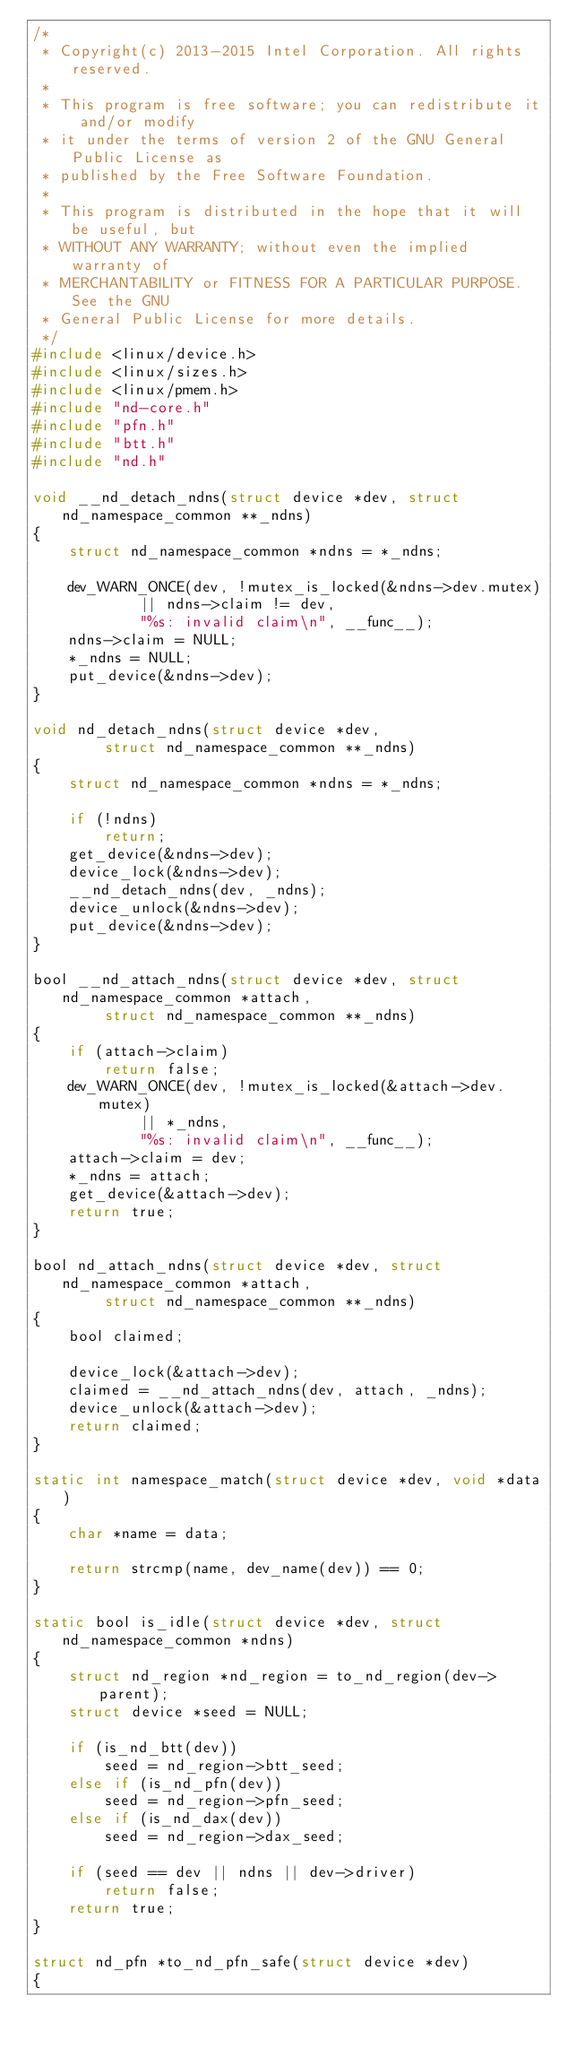Convert code to text. <code><loc_0><loc_0><loc_500><loc_500><_C_>/*
 * Copyright(c) 2013-2015 Intel Corporation. All rights reserved.
 *
 * This program is free software; you can redistribute it and/or modify
 * it under the terms of version 2 of the GNU General Public License as
 * published by the Free Software Foundation.
 *
 * This program is distributed in the hope that it will be useful, but
 * WITHOUT ANY WARRANTY; without even the implied warranty of
 * MERCHANTABILITY or FITNESS FOR A PARTICULAR PURPOSE.  See the GNU
 * General Public License for more details.
 */
#include <linux/device.h>
#include <linux/sizes.h>
#include <linux/pmem.h>
#include "nd-core.h"
#include "pfn.h"
#include "btt.h"
#include "nd.h"

void __nd_detach_ndns(struct device *dev, struct nd_namespace_common **_ndns)
{
	struct nd_namespace_common *ndns = *_ndns;

	dev_WARN_ONCE(dev, !mutex_is_locked(&ndns->dev.mutex)
			|| ndns->claim != dev,
			"%s: invalid claim\n", __func__);
	ndns->claim = NULL;
	*_ndns = NULL;
	put_device(&ndns->dev);
}

void nd_detach_ndns(struct device *dev,
		struct nd_namespace_common **_ndns)
{
	struct nd_namespace_common *ndns = *_ndns;

	if (!ndns)
		return;
	get_device(&ndns->dev);
	device_lock(&ndns->dev);
	__nd_detach_ndns(dev, _ndns);
	device_unlock(&ndns->dev);
	put_device(&ndns->dev);
}

bool __nd_attach_ndns(struct device *dev, struct nd_namespace_common *attach,
		struct nd_namespace_common **_ndns)
{
	if (attach->claim)
		return false;
	dev_WARN_ONCE(dev, !mutex_is_locked(&attach->dev.mutex)
			|| *_ndns,
			"%s: invalid claim\n", __func__);
	attach->claim = dev;
	*_ndns = attach;
	get_device(&attach->dev);
	return true;
}

bool nd_attach_ndns(struct device *dev, struct nd_namespace_common *attach,
		struct nd_namespace_common **_ndns)
{
	bool claimed;

	device_lock(&attach->dev);
	claimed = __nd_attach_ndns(dev, attach, _ndns);
	device_unlock(&attach->dev);
	return claimed;
}

static int namespace_match(struct device *dev, void *data)
{
	char *name = data;

	return strcmp(name, dev_name(dev)) == 0;
}

static bool is_idle(struct device *dev, struct nd_namespace_common *ndns)
{
	struct nd_region *nd_region = to_nd_region(dev->parent);
	struct device *seed = NULL;

	if (is_nd_btt(dev))
		seed = nd_region->btt_seed;
	else if (is_nd_pfn(dev))
		seed = nd_region->pfn_seed;
	else if (is_nd_dax(dev))
		seed = nd_region->dax_seed;

	if (seed == dev || ndns || dev->driver)
		return false;
	return true;
}

struct nd_pfn *to_nd_pfn_safe(struct device *dev)
{</code> 